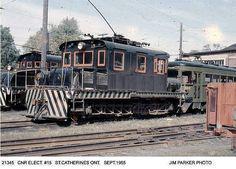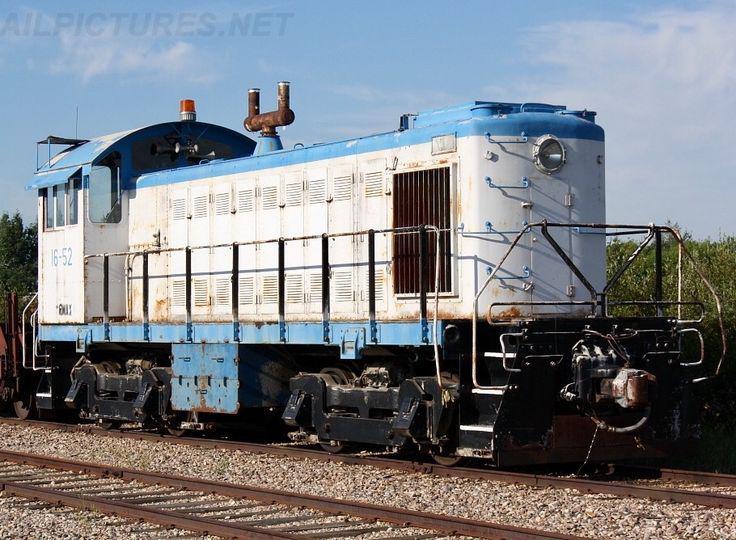The first image is the image on the left, the second image is the image on the right. Considering the images on both sides, is "There is a blue train facing right." valid? Answer yes or no. Yes. The first image is the image on the left, the second image is the image on the right. Examine the images to the left and right. Is the description "A train with three windows across the front is angled so it points right." accurate? Answer yes or no. No. 